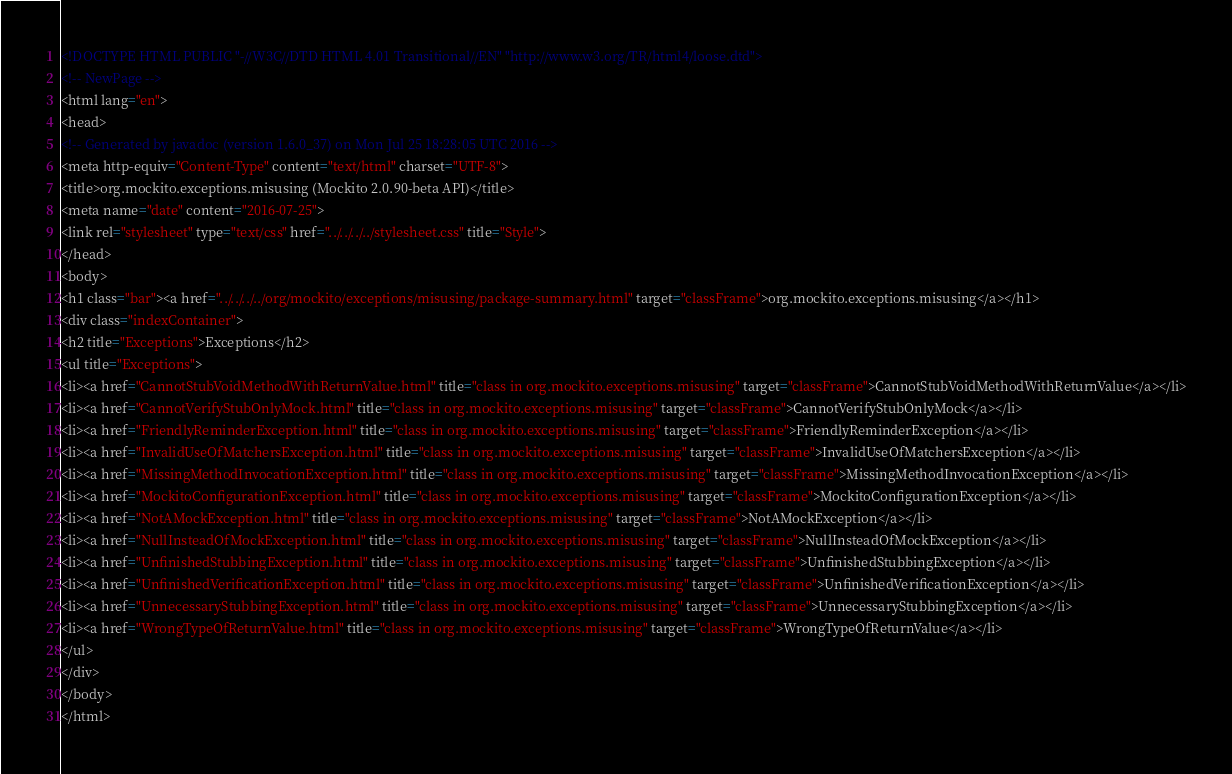<code> <loc_0><loc_0><loc_500><loc_500><_HTML_><!DOCTYPE HTML PUBLIC "-//W3C//DTD HTML 4.01 Transitional//EN" "http://www.w3.org/TR/html4/loose.dtd">
<!-- NewPage -->
<html lang="en">
<head>
<!-- Generated by javadoc (version 1.6.0_37) on Mon Jul 25 18:28:05 UTC 2016 -->
<meta http-equiv="Content-Type" content="text/html" charset="UTF-8">
<title>org.mockito.exceptions.misusing (Mockito 2.0.90-beta API)</title>
<meta name="date" content="2016-07-25">
<link rel="stylesheet" type="text/css" href="../../../../stylesheet.css" title="Style">
</head>
<body>
<h1 class="bar"><a href="../../../../org/mockito/exceptions/misusing/package-summary.html" target="classFrame">org.mockito.exceptions.misusing</a></h1>
<div class="indexContainer">
<h2 title="Exceptions">Exceptions</h2>
<ul title="Exceptions">
<li><a href="CannotStubVoidMethodWithReturnValue.html" title="class in org.mockito.exceptions.misusing" target="classFrame">CannotStubVoidMethodWithReturnValue</a></li>
<li><a href="CannotVerifyStubOnlyMock.html" title="class in org.mockito.exceptions.misusing" target="classFrame">CannotVerifyStubOnlyMock</a></li>
<li><a href="FriendlyReminderException.html" title="class in org.mockito.exceptions.misusing" target="classFrame">FriendlyReminderException</a></li>
<li><a href="InvalidUseOfMatchersException.html" title="class in org.mockito.exceptions.misusing" target="classFrame">InvalidUseOfMatchersException</a></li>
<li><a href="MissingMethodInvocationException.html" title="class in org.mockito.exceptions.misusing" target="classFrame">MissingMethodInvocationException</a></li>
<li><a href="MockitoConfigurationException.html" title="class in org.mockito.exceptions.misusing" target="classFrame">MockitoConfigurationException</a></li>
<li><a href="NotAMockException.html" title="class in org.mockito.exceptions.misusing" target="classFrame">NotAMockException</a></li>
<li><a href="NullInsteadOfMockException.html" title="class in org.mockito.exceptions.misusing" target="classFrame">NullInsteadOfMockException</a></li>
<li><a href="UnfinishedStubbingException.html" title="class in org.mockito.exceptions.misusing" target="classFrame">UnfinishedStubbingException</a></li>
<li><a href="UnfinishedVerificationException.html" title="class in org.mockito.exceptions.misusing" target="classFrame">UnfinishedVerificationException</a></li>
<li><a href="UnnecessaryStubbingException.html" title="class in org.mockito.exceptions.misusing" target="classFrame">UnnecessaryStubbingException</a></li>
<li><a href="WrongTypeOfReturnValue.html" title="class in org.mockito.exceptions.misusing" target="classFrame">WrongTypeOfReturnValue</a></li>
</ul>
</div>
</body>
</html>
</code> 